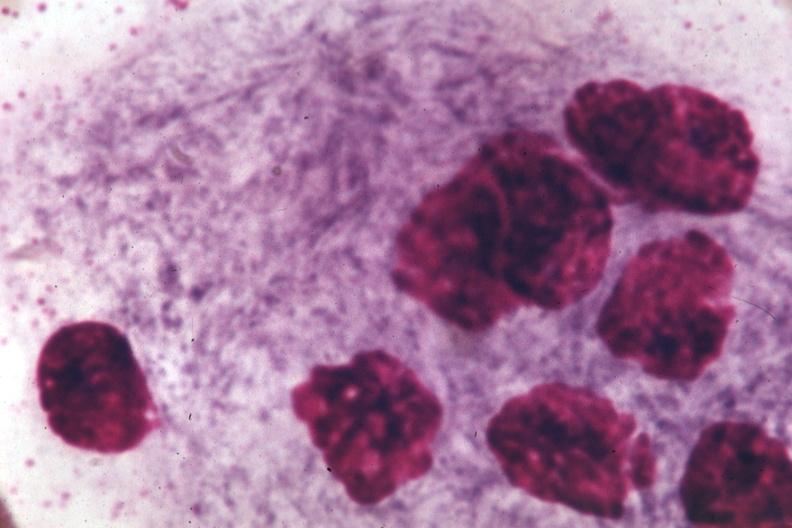s peritoneum present?
Answer the question using a single word or phrase. No 